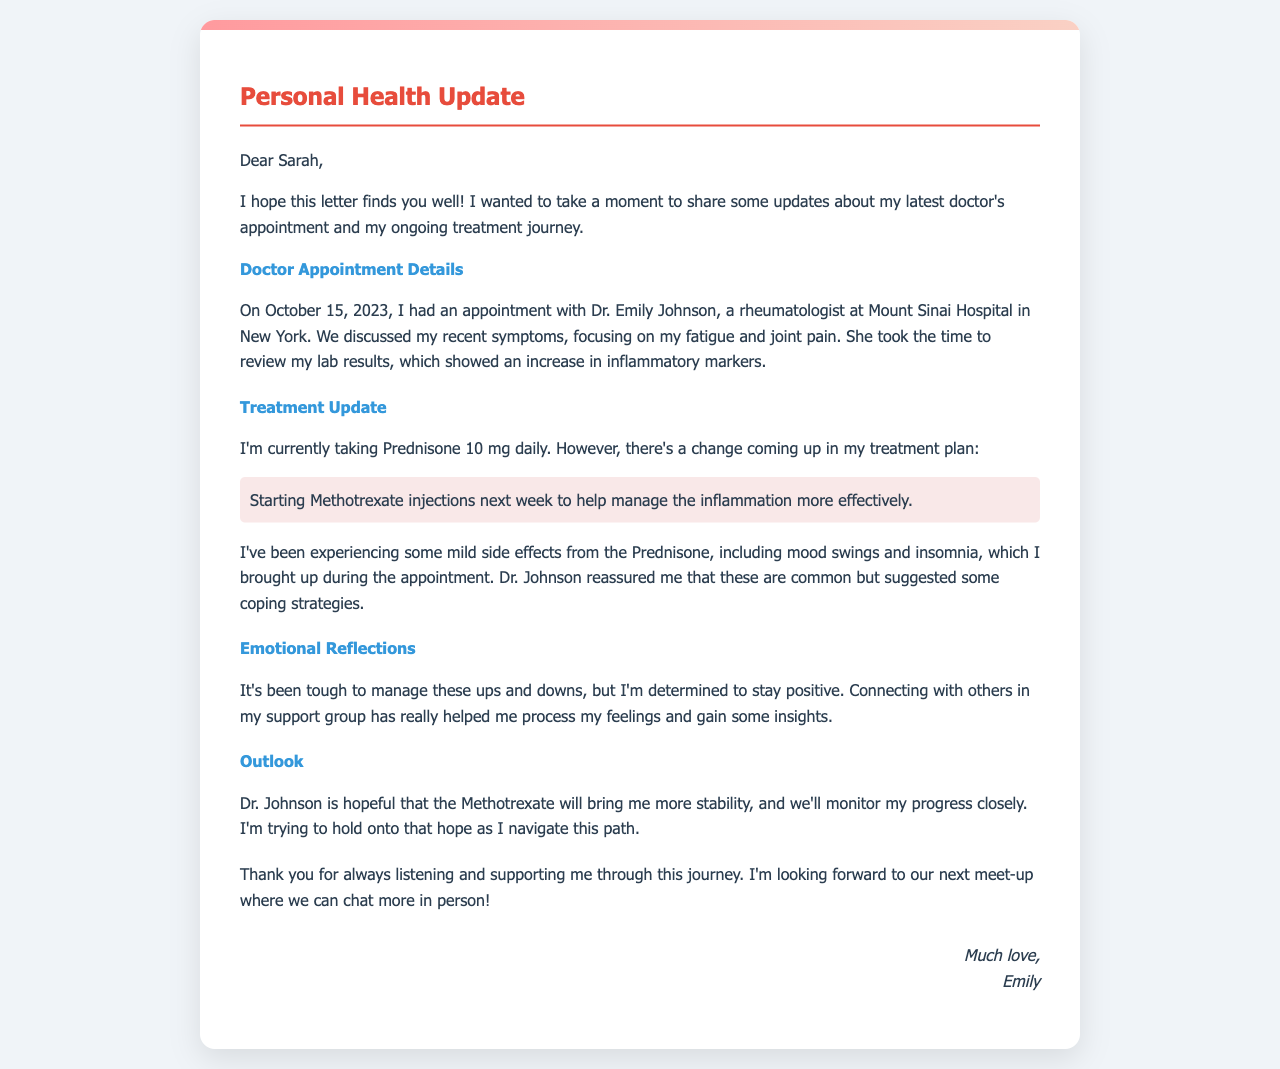What date was the doctor's appointment? The appointment date is explicitly mentioned in the letter as October 15, 2023.
Answer: October 15, 2023 Who was the doctor that Emily saw? The letter states that Emily had an appointment with Dr. Emily Johnson.
Answer: Dr. Emily Johnson What medication is Emily currently taking? The letter mentions that Emily is currently taking Prednisone 10 mg daily.
Answer: Prednisone 10 mg What new treatment is Emily starting next week? The letter details that Emily is starting Methotrexate injections next week.
Answer: Methotrexate injections What are some mild side effects Emily is experiencing? The letter lists mood swings and insomnia as mild side effects from the Prednisone.
Answer: Mood swings and insomnia How does Emily feel about her treatment progress? The letter indicates that Emily is trying to hold onto hope as she navigates her treatment path.
Answer: Hopeful What kind of support does Emily find helpful? The letter explains that connecting with others in her support group has been helpful for Emily.
Answer: Support group What does Dr. Johnson think about the new treatment? The letter mentions that Dr. Johnson is hopeful that the Methotrexate will bring Emily more stability.
Answer: Hopeful about stability 